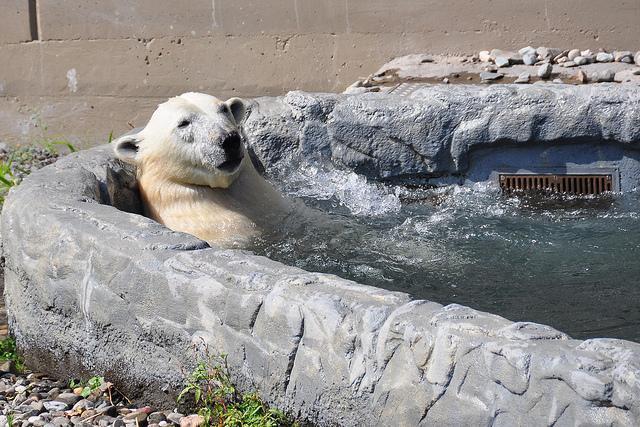How many bears can you see?
Give a very brief answer. 1. 